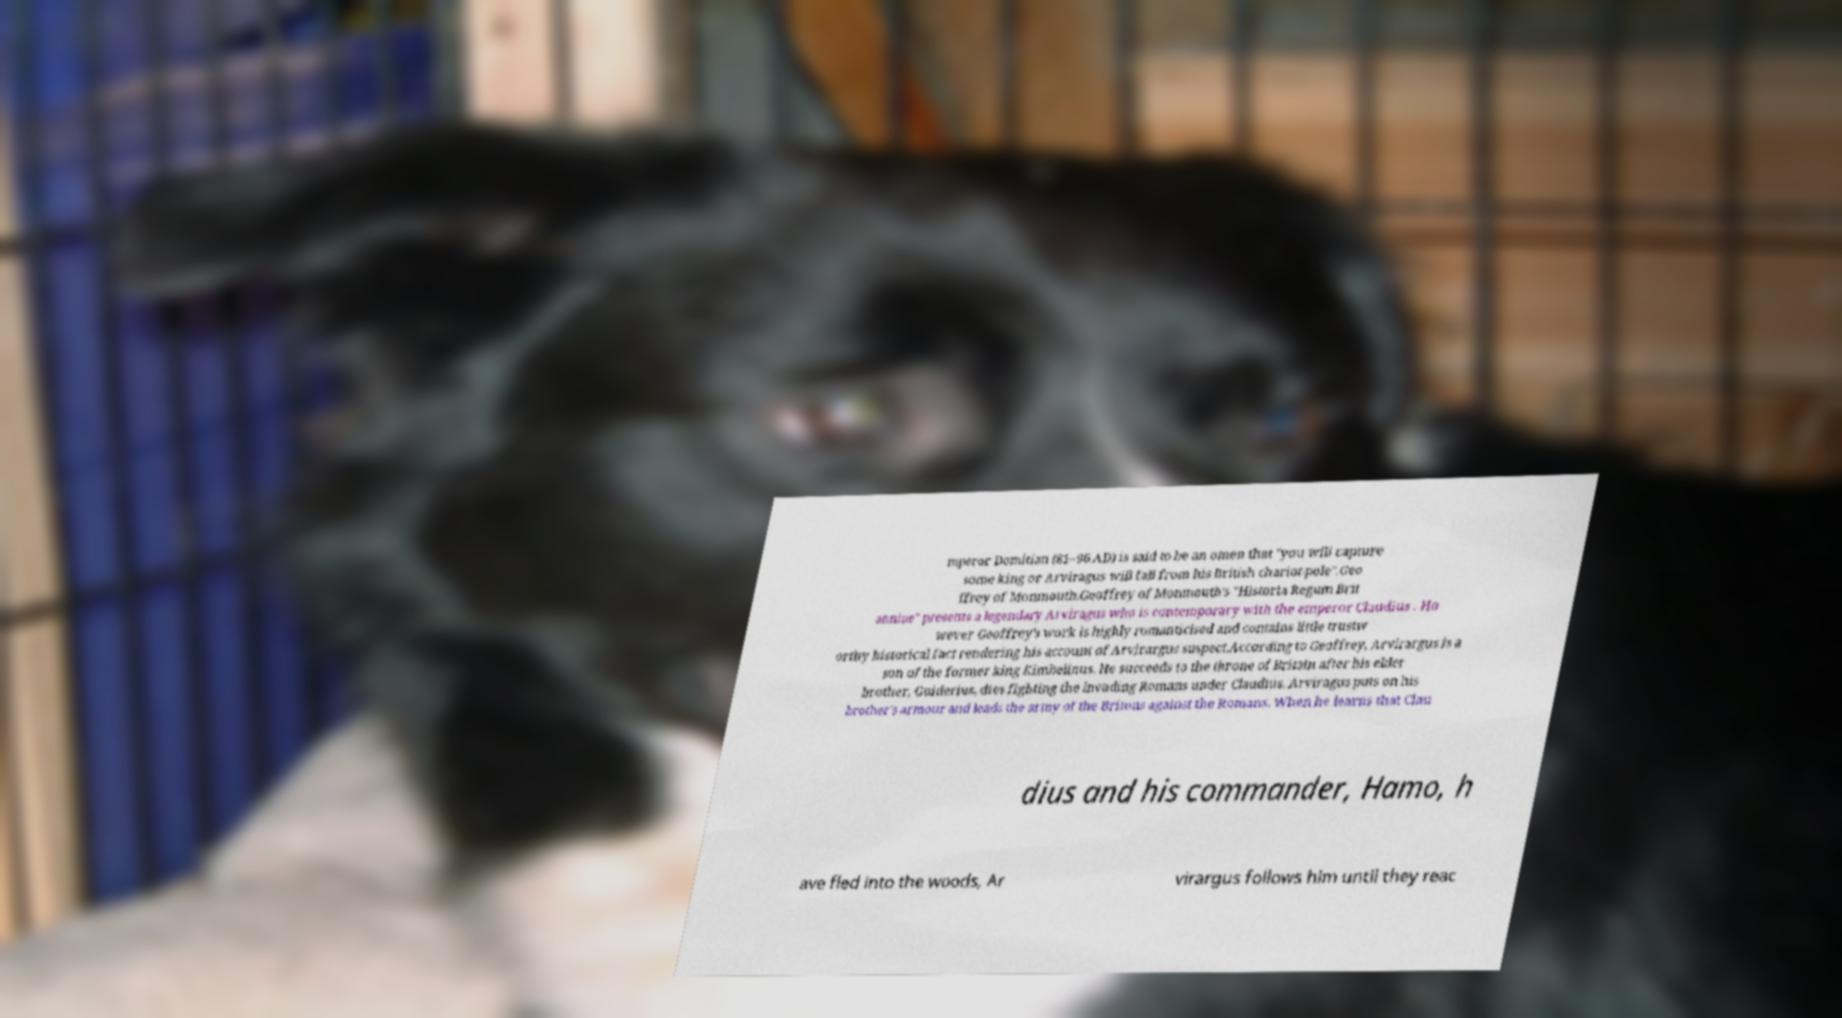Could you extract and type out the text from this image? mperor Domitian (81–96 AD) is said to be an omen that "you will capture some king or Arviragus will fall from his British chariot-pole".Geo ffrey of Monmouth.Geoffrey of Monmouth's "Historia Regum Brit anniae" presents a legendary Arviragus who is contemporary with the emperor Claudius . Ho wever Geoffrey's work is highly romanticised and contains little trustw orthy historical fact rendering his account of Arvirargus suspect.According to Geoffrey, Arvirargus is a son of the former king Kimbelinus. He succeeds to the throne of Britain after his elder brother, Guiderius, dies fighting the invading Romans under Claudius. Arviragus puts on his brother's armour and leads the army of the Britons against the Romans. When he learns that Clau dius and his commander, Hamo, h ave fled into the woods, Ar virargus follows him until they reac 